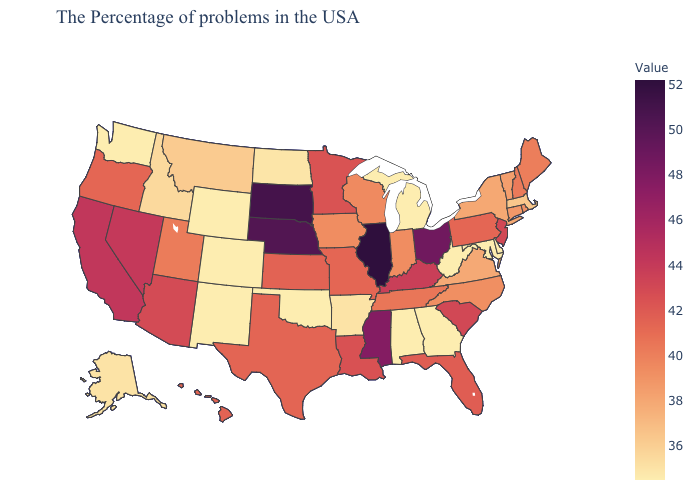Does Iowa have the highest value in the MidWest?
Short answer required. No. 